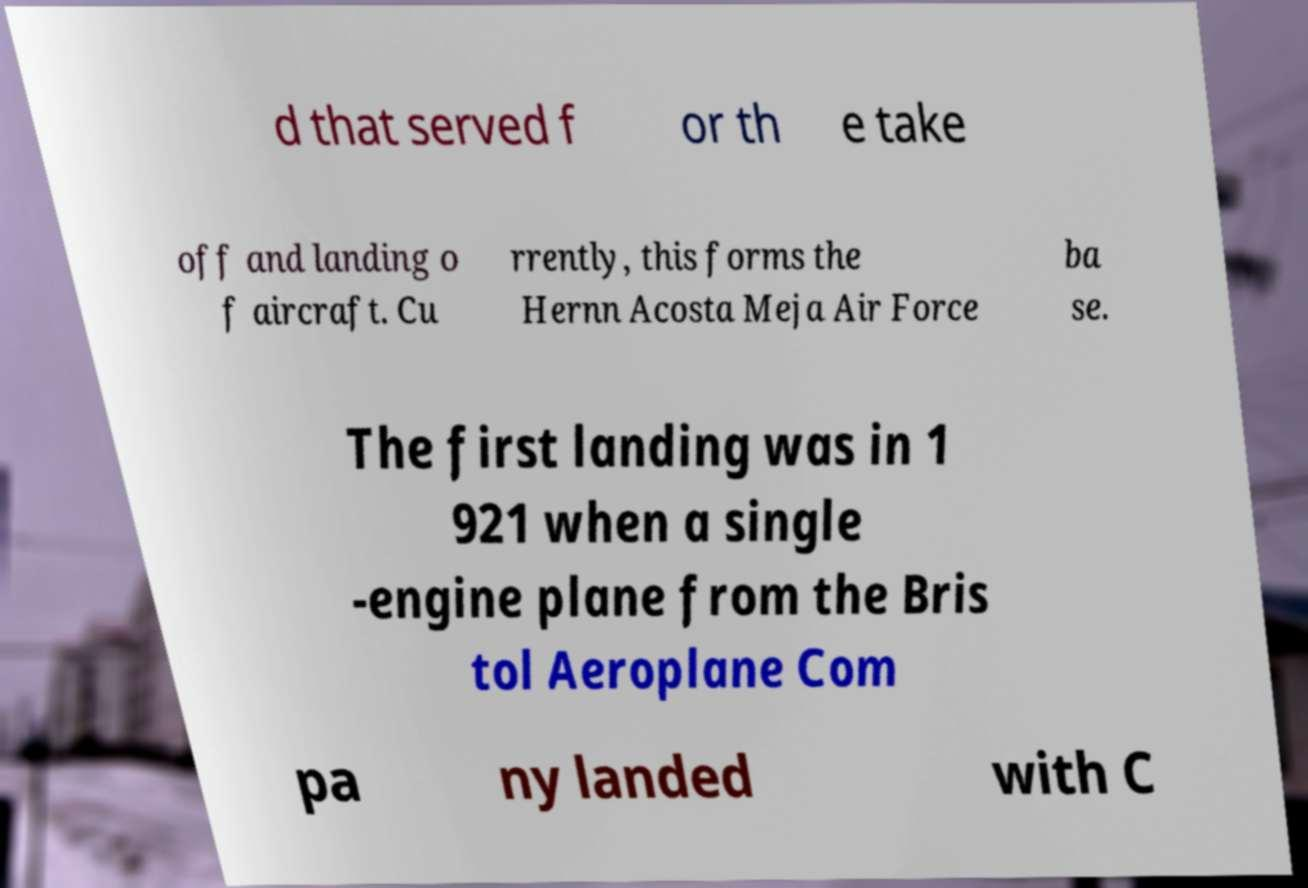Please read and relay the text visible in this image. What does it say? d that served f or th e take off and landing o f aircraft. Cu rrently, this forms the Hernn Acosta Meja Air Force ba se. The first landing was in 1 921 when a single -engine plane from the Bris tol Aeroplane Com pa ny landed with C 